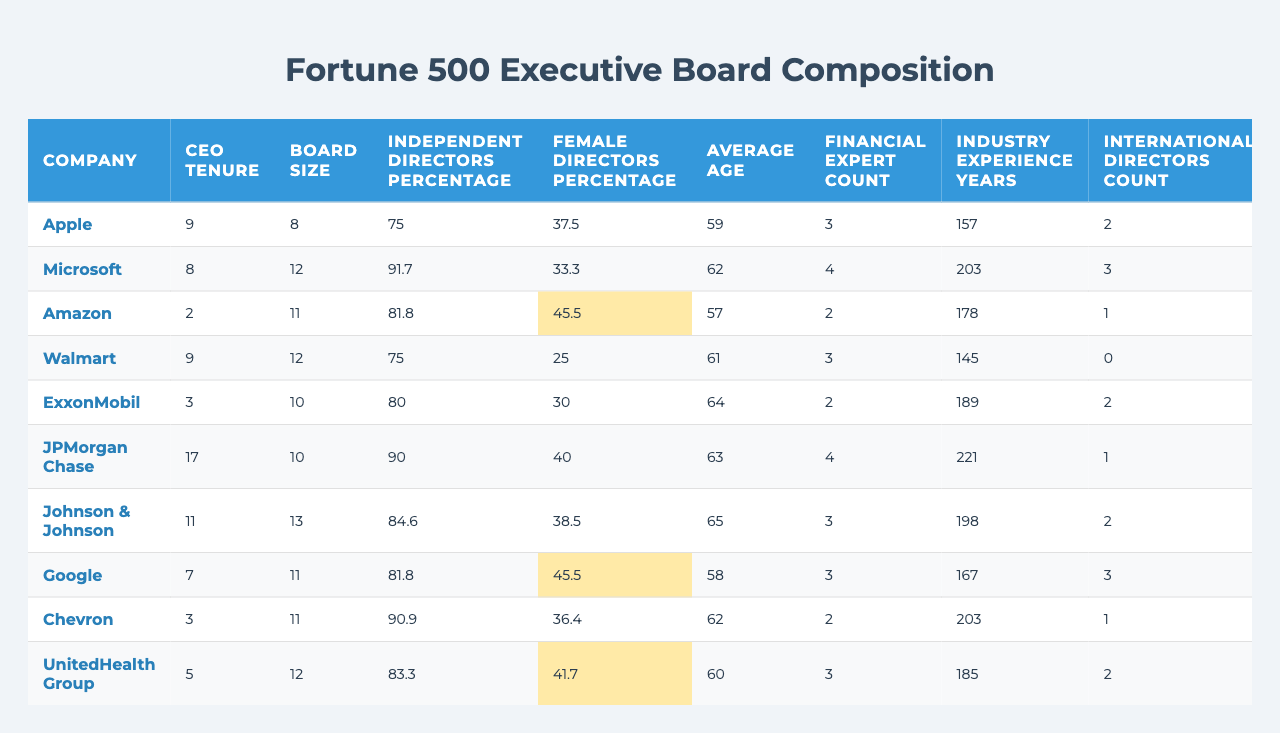What is the average CEO tenure among the listed companies? The CEO tenures are 9, 8, 2, 9, 3, 17, 11, 7, 3, and 5 years. To find the average, sum these values: 9 + 8 + 2 + 9 + 3 + 17 + 11 + 7 + 3 + 5 = 74. Then divide by the number of companies (10): 74 / 10 = 7.4
Answer: 7.4 Which company has the highest percentage of independent directors? The independent directors percentages are: 75, 91.7, 81.8, 75, 80, 90, 84.6, 81.8, 90.9, and 83.3. The maximum value is 91.7%, which belongs to Microsoft.
Answer: Microsoft Is the percentage of female directors at Amazon greater than the average of the female directors' percentages across all companies? The female directors percentages are 37.5, 33.3, 45.5, 25, 30, 40, 38.5, 45.5, 36.4, and 41.7. The average is calculated as (37.5 + 33.3 + 45.5 + 25 + 30 + 40 + 38.5 + 45.5 + 36.4 + 41.7) / 10 = 37.5. Since Amazon's percentage is 45.5, it is indeed greater than the average.
Answer: Yes How does the average CEO compensation compare to the average board size? The CEO compensations are 99.4, 42.9, 212.7, 25.7, 23.6, 34.5, 29.6, 280.6, 22.8, and 18.9. Their average is: (99.4 + 42.9 + 212.7 + 25.7 + 23.6 + 34.5 + 29.6 + 280.6 + 22.8 + 18.9) / 10 =  91.27 million. The board sizes are 8, 12, 11, 12, 10, 10, 13, 11, 11, and 12, which average to 11.2. Since 91.27 million is much larger than 11.2, we conclude that the CEO compensation average is significantly higher than average board size.
Answer: Yes Which company has both the highest financial expert count and CEO compensation? The financial expert counts are 3, 4, 2, 3, 2, 4, 3, 3, 2, and 3, and the CEO compensations are 99.4, 42.9, 212.7, 25.7, 23.6, 34.5, 29.6, 280.6, 22.8, and 18.9. The maximum financial expert count is 4 (Microsoft and JPMorgan Chase), but the highest CEO compensation is 280.6 (Alphabet). Since the two maximums do not coincide, no single company meets both criteria, so the answer is no.
Answer: No 